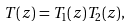Convert formula to latex. <formula><loc_0><loc_0><loc_500><loc_500>T ( z ) = T _ { 1 } ( z ) T _ { 2 } ( z ) ,</formula> 